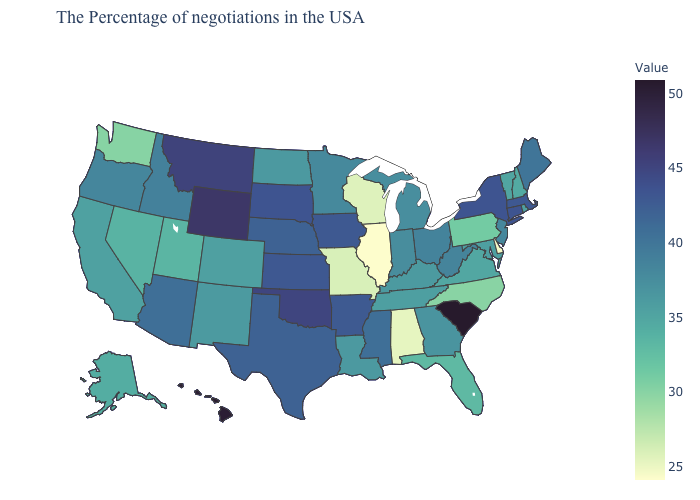Does Washington have the lowest value in the West?
Answer briefly. Yes. Does Utah have a lower value than Delaware?
Short answer required. No. Which states have the lowest value in the South?
Keep it brief. Delaware. Among the states that border Wyoming , which have the lowest value?
Give a very brief answer. Utah. Does the map have missing data?
Give a very brief answer. No. Among the states that border South Dakota , does Montana have the highest value?
Answer briefly. No. 